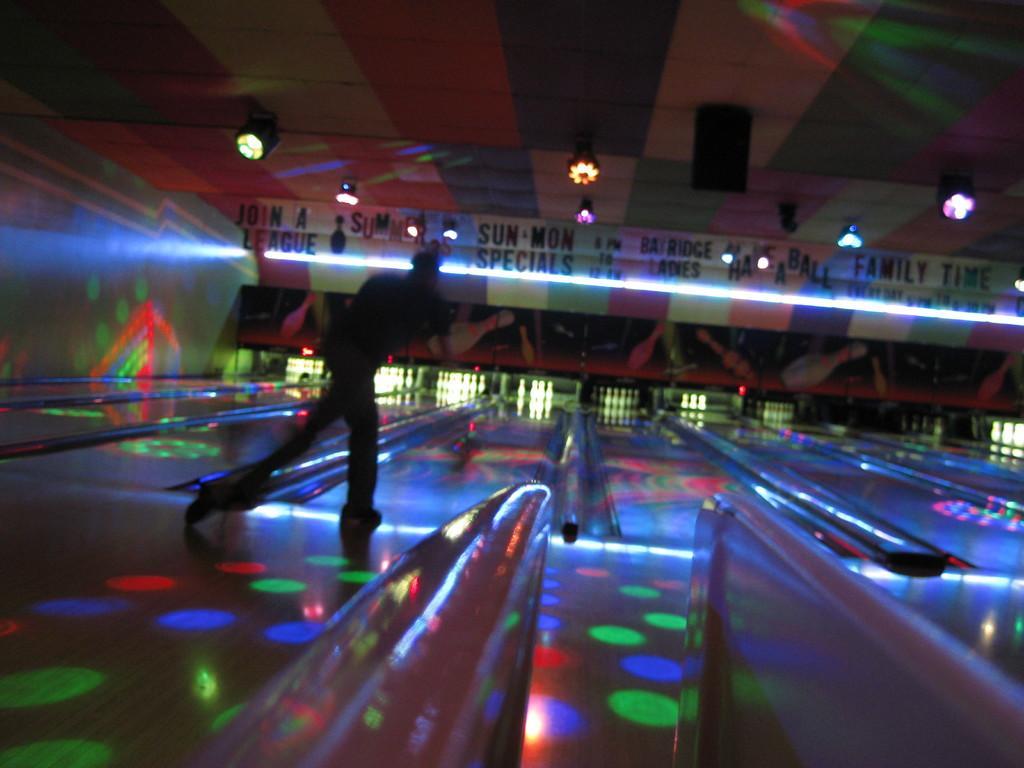Can you describe this image briefly? In this picture I can see the bowling coach. On the left there is a man who is throwing the ball. In the background I can see the pins. At the top there is a speaker and lights on the roof. At the bottom I can see the light beams in different colors. 